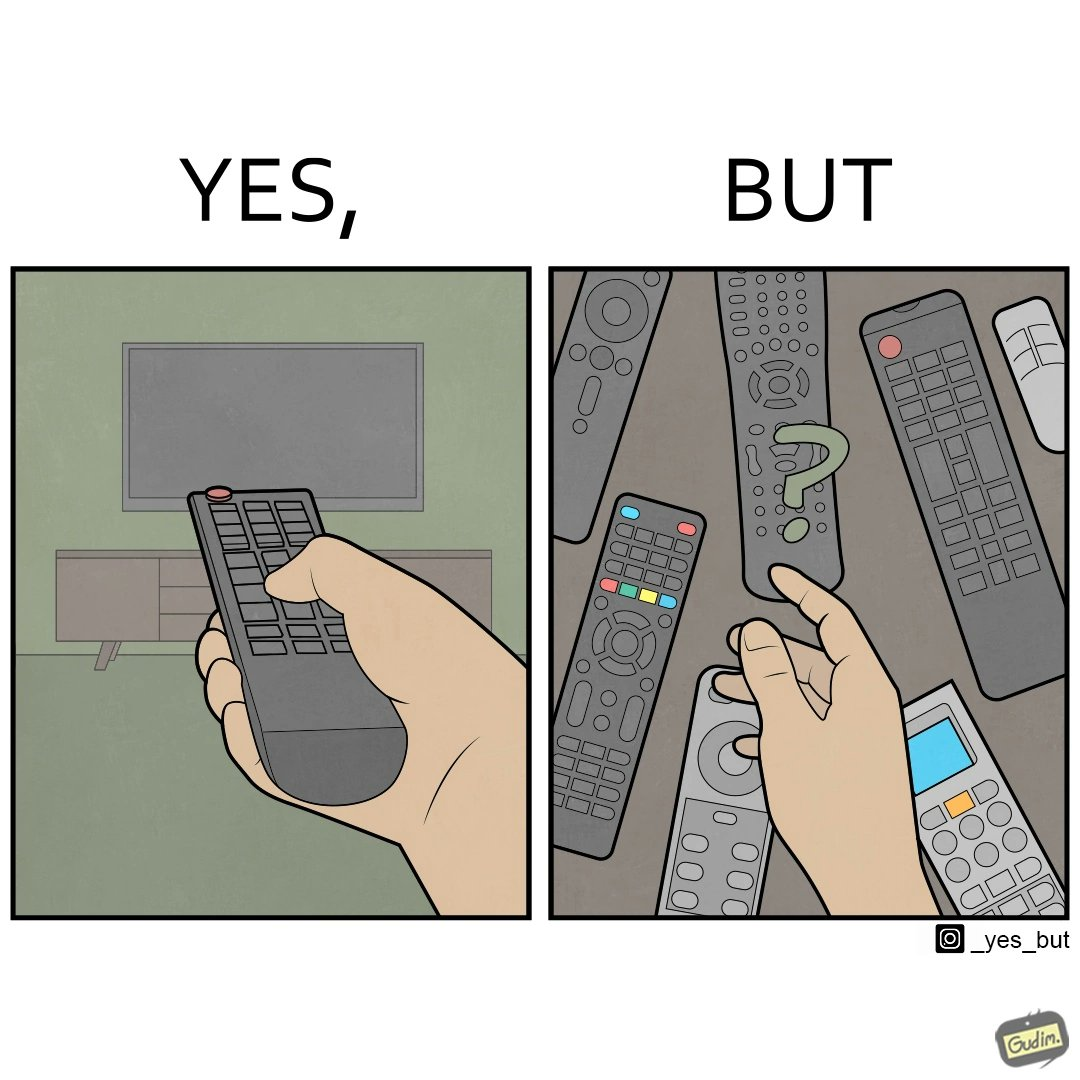Describe the content of this image. The images are funny since they show how even though TV remotes are supposed to make operating TVs easier, having multiple similar looking remotes  for everything only makes it more difficult for the user to use the right one 